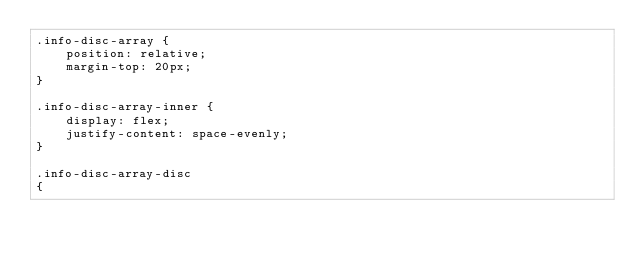<code> <loc_0><loc_0><loc_500><loc_500><_CSS_>.info-disc-array {
    position: relative;
    margin-top: 20px;
}

.info-disc-array-inner {
    display: flex;
    justify-content: space-evenly;
}

.info-disc-array-disc
{</code> 